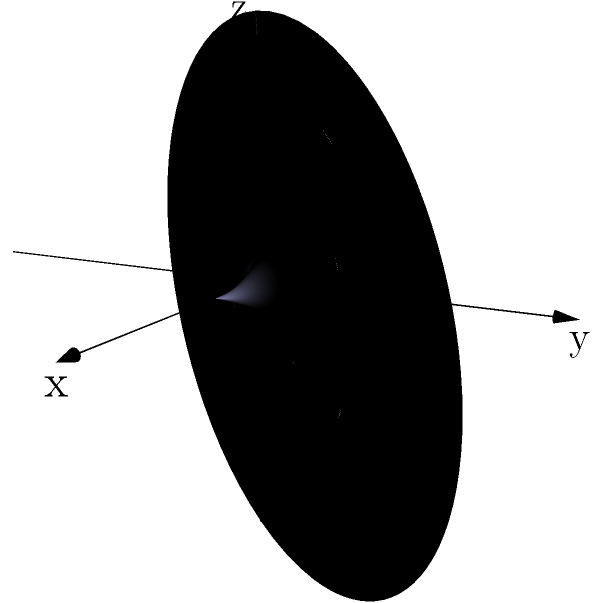Consider a hyperbola with equation $\frac{x^2}{a^2} - \frac{y^2}{b^2} = 1$, where $a=2$ and $b=1$. If this hyperbola is rotated around its transverse axis (x-axis), what three-dimensional shape is formed? How does this shape relate to the concept of ethical behavior without religious influence? To solve this problem, let's break it down into steps:

1) The given hyperbola equation is $\frac{x^2}{4} - y^2 = 1$.

2) When this hyperbola is rotated around the x-axis, it forms a hyperboloid of one sheet.

3) The parametric equations for this hyperboloid are:
   $$x = a \cosh(u) \cos(v)$$
   $$y = b \sinh(u) \cos(v)$$
   $$z = b \sinh(u) \sin(v)$$
   where $0 \leq u < \infty$ and $0 \leq v < 2\pi$.

4) The hyperboloid of one sheet is a doubly ruled surface, meaning it can be generated by two different sets of straight lines.

5) Relating this to the sociological perspective on ethics without religion:
   - The hyperboloid's complex structure from simple rotation mirrors how ethical behavior can emerge from rational thought and social interaction, without needing religious doctrine.
   - The two sets of lines generating the surface could represent different ethical frameworks (e.g., utilitarianism and deontology) that can lead to similar ethical outcomes.
   - The continuity and symmetry of the shape might symbolize the universality of certain ethical principles across cultures, independent of religious beliefs.
   - The open nature of the hyperboloid could represent the openness and adaptability of secular ethical systems.

6) This geometric analogy demonstrates that complex ethical structures can arise from basic principles, just as a complex 3D shape emerges from a simple 2D curve rotation.
Answer: Hyperboloid of one sheet; symbolizes emergence of complex ethical structures from basic principles without religious influence. 